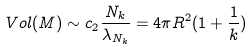Convert formula to latex. <formula><loc_0><loc_0><loc_500><loc_500>V o l ( M ) \sim c _ { 2 } \frac { N _ { k } } { \lambda _ { N _ { k } } } = 4 \pi R ^ { 2 } ( 1 + \frac { 1 } { k } )</formula> 